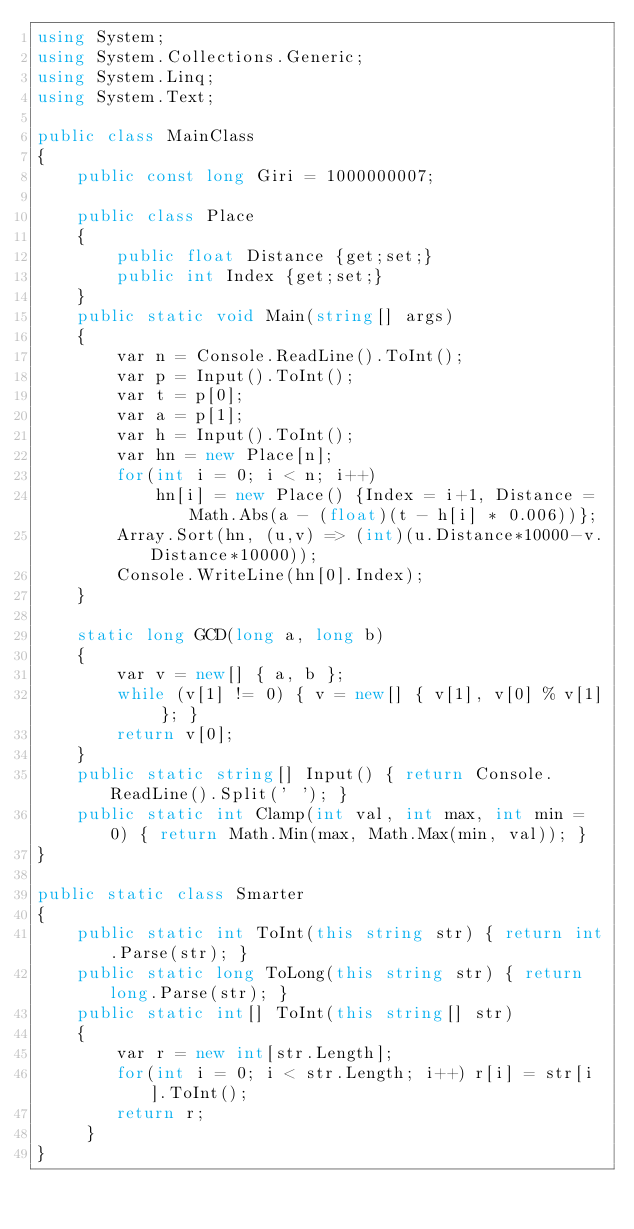Convert code to text. <code><loc_0><loc_0><loc_500><loc_500><_C#_>using System;
using System.Collections.Generic;
using System.Linq;
using System.Text;

public class MainClass
{
	public const long Giri = 1000000007;

	public class Place
	{
		public float Distance {get;set;}
		public int Index {get;set;}
	}
	public static void Main(string[] args)
	{
		var n = Console.ReadLine().ToInt();
		var p = Input().ToInt();
		var t = p[0];
		var a = p[1];
		var h = Input().ToInt();
		var hn = new Place[n];
		for(int i = 0; i < n; i++)
			hn[i] = new Place() {Index = i+1, Distance = Math.Abs(a - (float)(t - h[i] * 0.006))};
		Array.Sort(hn, (u,v) => (int)(u.Distance*10000-v.Distance*10000));
		Console.WriteLine(hn[0].Index);
	}
	
	static long GCD(long a, long b)
	{
		var v = new[] { a, b };
		while (v[1] != 0) { v = new[] { v[1], v[0] % v[1] }; }
		return v[0];
	}
	public static string[] Input() { return Console.ReadLine().Split(' '); }
	public static int Clamp(int val, int max, int min = 0) { return Math.Min(max, Math.Max(min, val)); }
}

public static class Smarter
{
	public static int ToInt(this string str) { return int.Parse(str); }
	public static long ToLong(this string str) { return long.Parse(str); }
	public static int[] ToInt(this string[] str)
	{
		var r = new int[str.Length];
		for(int i = 0; i < str.Length; i++) r[i] = str[i].ToInt();
		return r;
	 }
}

</code> 